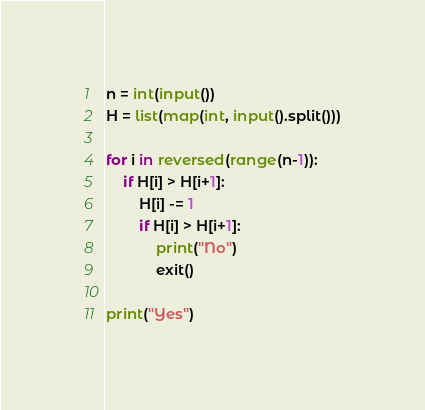<code> <loc_0><loc_0><loc_500><loc_500><_Python_>n = int(input())
H = list(map(int, input().split()))

for i in reversed(range(n-1)):
    if H[i] > H[i+1]:
        H[i] -= 1
        if H[i] > H[i+1]:
            print("No")
            exit()

print("Yes")</code> 